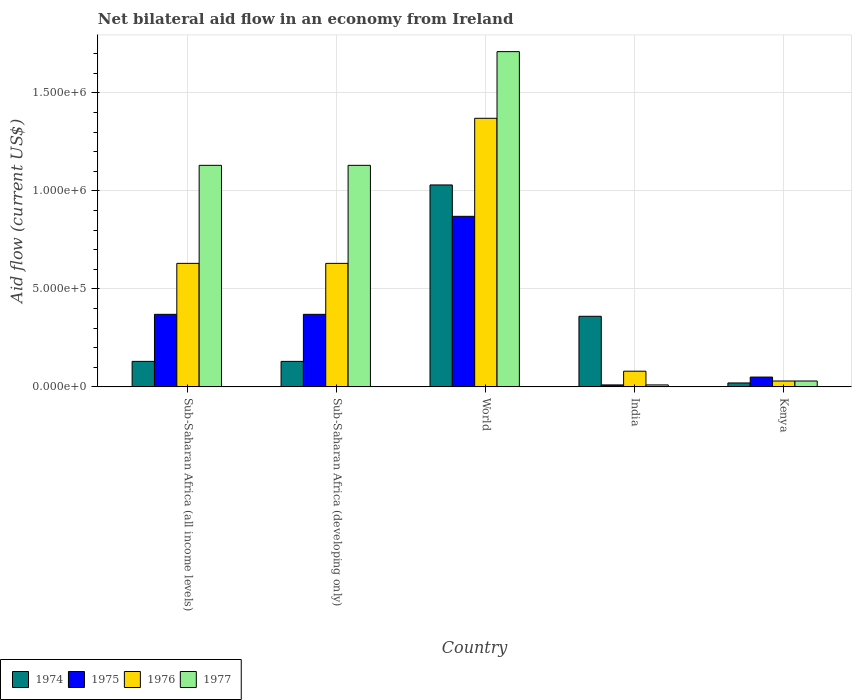How many different coloured bars are there?
Make the answer very short. 4. How many groups of bars are there?
Give a very brief answer. 5. Are the number of bars on each tick of the X-axis equal?
Your answer should be very brief. Yes. How many bars are there on the 2nd tick from the left?
Give a very brief answer. 4. What is the label of the 4th group of bars from the left?
Ensure brevity in your answer.  India. What is the net bilateral aid flow in 1977 in World?
Offer a terse response. 1.71e+06. Across all countries, what is the maximum net bilateral aid flow in 1976?
Ensure brevity in your answer.  1.37e+06. Across all countries, what is the minimum net bilateral aid flow in 1975?
Ensure brevity in your answer.  10000. In which country was the net bilateral aid flow in 1977 minimum?
Your answer should be very brief. India. What is the total net bilateral aid flow in 1977 in the graph?
Provide a succinct answer. 4.01e+06. What is the difference between the net bilateral aid flow in 1976 in Sub-Saharan Africa (developing only) and that in World?
Provide a succinct answer. -7.40e+05. What is the difference between the net bilateral aid flow in 1976 in Kenya and the net bilateral aid flow in 1977 in Sub-Saharan Africa (developing only)?
Ensure brevity in your answer.  -1.10e+06. What is the average net bilateral aid flow in 1974 per country?
Your response must be concise. 3.34e+05. What is the difference between the net bilateral aid flow of/in 1976 and net bilateral aid flow of/in 1975 in India?
Ensure brevity in your answer.  7.00e+04. What is the ratio of the net bilateral aid flow in 1974 in India to that in Kenya?
Offer a terse response. 18. Is the net bilateral aid flow in 1977 in Sub-Saharan Africa (developing only) less than that in World?
Provide a short and direct response. Yes. What is the difference between the highest and the second highest net bilateral aid flow in 1977?
Provide a short and direct response. 5.80e+05. What is the difference between the highest and the lowest net bilateral aid flow in 1974?
Ensure brevity in your answer.  1.01e+06. In how many countries, is the net bilateral aid flow in 1977 greater than the average net bilateral aid flow in 1977 taken over all countries?
Make the answer very short. 3. What does the 3rd bar from the left in World represents?
Your answer should be very brief. 1976. What does the 2nd bar from the right in Sub-Saharan Africa (all income levels) represents?
Offer a very short reply. 1976. How many bars are there?
Your answer should be very brief. 20. Are all the bars in the graph horizontal?
Your answer should be very brief. No. Are the values on the major ticks of Y-axis written in scientific E-notation?
Your answer should be compact. Yes. Does the graph contain any zero values?
Make the answer very short. No. Where does the legend appear in the graph?
Provide a succinct answer. Bottom left. How many legend labels are there?
Give a very brief answer. 4. How are the legend labels stacked?
Give a very brief answer. Horizontal. What is the title of the graph?
Provide a succinct answer. Net bilateral aid flow in an economy from Ireland. What is the label or title of the X-axis?
Offer a very short reply. Country. What is the label or title of the Y-axis?
Give a very brief answer. Aid flow (current US$). What is the Aid flow (current US$) of 1974 in Sub-Saharan Africa (all income levels)?
Offer a terse response. 1.30e+05. What is the Aid flow (current US$) of 1976 in Sub-Saharan Africa (all income levels)?
Offer a terse response. 6.30e+05. What is the Aid flow (current US$) in 1977 in Sub-Saharan Africa (all income levels)?
Ensure brevity in your answer.  1.13e+06. What is the Aid flow (current US$) in 1974 in Sub-Saharan Africa (developing only)?
Provide a succinct answer. 1.30e+05. What is the Aid flow (current US$) in 1976 in Sub-Saharan Africa (developing only)?
Your answer should be compact. 6.30e+05. What is the Aid flow (current US$) of 1977 in Sub-Saharan Africa (developing only)?
Provide a succinct answer. 1.13e+06. What is the Aid flow (current US$) of 1974 in World?
Your response must be concise. 1.03e+06. What is the Aid flow (current US$) of 1975 in World?
Keep it short and to the point. 8.70e+05. What is the Aid flow (current US$) of 1976 in World?
Offer a very short reply. 1.37e+06. What is the Aid flow (current US$) of 1977 in World?
Offer a very short reply. 1.71e+06. What is the Aid flow (current US$) in 1974 in India?
Make the answer very short. 3.60e+05. What is the Aid flow (current US$) of 1976 in India?
Provide a succinct answer. 8.00e+04. What is the Aid flow (current US$) in 1974 in Kenya?
Provide a succinct answer. 2.00e+04. What is the Aid flow (current US$) in 1976 in Kenya?
Your answer should be very brief. 3.00e+04. Across all countries, what is the maximum Aid flow (current US$) in 1974?
Offer a terse response. 1.03e+06. Across all countries, what is the maximum Aid flow (current US$) in 1975?
Your response must be concise. 8.70e+05. Across all countries, what is the maximum Aid flow (current US$) of 1976?
Give a very brief answer. 1.37e+06. Across all countries, what is the maximum Aid flow (current US$) of 1977?
Offer a very short reply. 1.71e+06. Across all countries, what is the minimum Aid flow (current US$) in 1976?
Keep it short and to the point. 3.00e+04. Across all countries, what is the minimum Aid flow (current US$) of 1977?
Your answer should be very brief. 10000. What is the total Aid flow (current US$) in 1974 in the graph?
Provide a succinct answer. 1.67e+06. What is the total Aid flow (current US$) in 1975 in the graph?
Your answer should be compact. 1.67e+06. What is the total Aid flow (current US$) of 1976 in the graph?
Keep it short and to the point. 2.74e+06. What is the total Aid flow (current US$) in 1977 in the graph?
Your answer should be compact. 4.01e+06. What is the difference between the Aid flow (current US$) in 1976 in Sub-Saharan Africa (all income levels) and that in Sub-Saharan Africa (developing only)?
Your response must be concise. 0. What is the difference between the Aid flow (current US$) of 1974 in Sub-Saharan Africa (all income levels) and that in World?
Your answer should be very brief. -9.00e+05. What is the difference between the Aid flow (current US$) in 1975 in Sub-Saharan Africa (all income levels) and that in World?
Ensure brevity in your answer.  -5.00e+05. What is the difference between the Aid flow (current US$) of 1976 in Sub-Saharan Africa (all income levels) and that in World?
Give a very brief answer. -7.40e+05. What is the difference between the Aid flow (current US$) in 1977 in Sub-Saharan Africa (all income levels) and that in World?
Your answer should be very brief. -5.80e+05. What is the difference between the Aid flow (current US$) in 1974 in Sub-Saharan Africa (all income levels) and that in India?
Offer a terse response. -2.30e+05. What is the difference between the Aid flow (current US$) of 1977 in Sub-Saharan Africa (all income levels) and that in India?
Keep it short and to the point. 1.12e+06. What is the difference between the Aid flow (current US$) of 1975 in Sub-Saharan Africa (all income levels) and that in Kenya?
Your response must be concise. 3.20e+05. What is the difference between the Aid flow (current US$) in 1976 in Sub-Saharan Africa (all income levels) and that in Kenya?
Ensure brevity in your answer.  6.00e+05. What is the difference between the Aid flow (current US$) of 1977 in Sub-Saharan Africa (all income levels) and that in Kenya?
Your response must be concise. 1.10e+06. What is the difference between the Aid flow (current US$) of 1974 in Sub-Saharan Africa (developing only) and that in World?
Offer a very short reply. -9.00e+05. What is the difference between the Aid flow (current US$) of 1975 in Sub-Saharan Africa (developing only) and that in World?
Ensure brevity in your answer.  -5.00e+05. What is the difference between the Aid flow (current US$) of 1976 in Sub-Saharan Africa (developing only) and that in World?
Keep it short and to the point. -7.40e+05. What is the difference between the Aid flow (current US$) of 1977 in Sub-Saharan Africa (developing only) and that in World?
Ensure brevity in your answer.  -5.80e+05. What is the difference between the Aid flow (current US$) in 1977 in Sub-Saharan Africa (developing only) and that in India?
Provide a succinct answer. 1.12e+06. What is the difference between the Aid flow (current US$) in 1974 in Sub-Saharan Africa (developing only) and that in Kenya?
Provide a succinct answer. 1.10e+05. What is the difference between the Aid flow (current US$) in 1976 in Sub-Saharan Africa (developing only) and that in Kenya?
Keep it short and to the point. 6.00e+05. What is the difference between the Aid flow (current US$) of 1977 in Sub-Saharan Africa (developing only) and that in Kenya?
Keep it short and to the point. 1.10e+06. What is the difference between the Aid flow (current US$) of 1974 in World and that in India?
Make the answer very short. 6.70e+05. What is the difference between the Aid flow (current US$) in 1975 in World and that in India?
Make the answer very short. 8.60e+05. What is the difference between the Aid flow (current US$) in 1976 in World and that in India?
Provide a short and direct response. 1.29e+06. What is the difference between the Aid flow (current US$) in 1977 in World and that in India?
Provide a short and direct response. 1.70e+06. What is the difference between the Aid flow (current US$) in 1974 in World and that in Kenya?
Your answer should be compact. 1.01e+06. What is the difference between the Aid flow (current US$) in 1975 in World and that in Kenya?
Provide a short and direct response. 8.20e+05. What is the difference between the Aid flow (current US$) in 1976 in World and that in Kenya?
Your response must be concise. 1.34e+06. What is the difference between the Aid flow (current US$) in 1977 in World and that in Kenya?
Give a very brief answer. 1.68e+06. What is the difference between the Aid flow (current US$) of 1974 in Sub-Saharan Africa (all income levels) and the Aid flow (current US$) of 1976 in Sub-Saharan Africa (developing only)?
Provide a short and direct response. -5.00e+05. What is the difference between the Aid flow (current US$) of 1975 in Sub-Saharan Africa (all income levels) and the Aid flow (current US$) of 1976 in Sub-Saharan Africa (developing only)?
Your response must be concise. -2.60e+05. What is the difference between the Aid flow (current US$) of 1975 in Sub-Saharan Africa (all income levels) and the Aid flow (current US$) of 1977 in Sub-Saharan Africa (developing only)?
Provide a short and direct response. -7.60e+05. What is the difference between the Aid flow (current US$) in 1976 in Sub-Saharan Africa (all income levels) and the Aid flow (current US$) in 1977 in Sub-Saharan Africa (developing only)?
Provide a short and direct response. -5.00e+05. What is the difference between the Aid flow (current US$) in 1974 in Sub-Saharan Africa (all income levels) and the Aid flow (current US$) in 1975 in World?
Your response must be concise. -7.40e+05. What is the difference between the Aid flow (current US$) of 1974 in Sub-Saharan Africa (all income levels) and the Aid flow (current US$) of 1976 in World?
Give a very brief answer. -1.24e+06. What is the difference between the Aid flow (current US$) in 1974 in Sub-Saharan Africa (all income levels) and the Aid flow (current US$) in 1977 in World?
Your answer should be very brief. -1.58e+06. What is the difference between the Aid flow (current US$) in 1975 in Sub-Saharan Africa (all income levels) and the Aid flow (current US$) in 1977 in World?
Make the answer very short. -1.34e+06. What is the difference between the Aid flow (current US$) of 1976 in Sub-Saharan Africa (all income levels) and the Aid flow (current US$) of 1977 in World?
Your response must be concise. -1.08e+06. What is the difference between the Aid flow (current US$) of 1974 in Sub-Saharan Africa (all income levels) and the Aid flow (current US$) of 1975 in India?
Make the answer very short. 1.20e+05. What is the difference between the Aid flow (current US$) of 1975 in Sub-Saharan Africa (all income levels) and the Aid flow (current US$) of 1976 in India?
Offer a very short reply. 2.90e+05. What is the difference between the Aid flow (current US$) of 1975 in Sub-Saharan Africa (all income levels) and the Aid flow (current US$) of 1977 in India?
Your response must be concise. 3.60e+05. What is the difference between the Aid flow (current US$) of 1976 in Sub-Saharan Africa (all income levels) and the Aid flow (current US$) of 1977 in India?
Your answer should be very brief. 6.20e+05. What is the difference between the Aid flow (current US$) in 1974 in Sub-Saharan Africa (all income levels) and the Aid flow (current US$) in 1977 in Kenya?
Offer a very short reply. 1.00e+05. What is the difference between the Aid flow (current US$) in 1975 in Sub-Saharan Africa (all income levels) and the Aid flow (current US$) in 1976 in Kenya?
Provide a short and direct response. 3.40e+05. What is the difference between the Aid flow (current US$) of 1975 in Sub-Saharan Africa (all income levels) and the Aid flow (current US$) of 1977 in Kenya?
Your answer should be very brief. 3.40e+05. What is the difference between the Aid flow (current US$) of 1976 in Sub-Saharan Africa (all income levels) and the Aid flow (current US$) of 1977 in Kenya?
Offer a terse response. 6.00e+05. What is the difference between the Aid flow (current US$) in 1974 in Sub-Saharan Africa (developing only) and the Aid flow (current US$) in 1975 in World?
Offer a very short reply. -7.40e+05. What is the difference between the Aid flow (current US$) of 1974 in Sub-Saharan Africa (developing only) and the Aid flow (current US$) of 1976 in World?
Give a very brief answer. -1.24e+06. What is the difference between the Aid flow (current US$) in 1974 in Sub-Saharan Africa (developing only) and the Aid flow (current US$) in 1977 in World?
Your response must be concise. -1.58e+06. What is the difference between the Aid flow (current US$) of 1975 in Sub-Saharan Africa (developing only) and the Aid flow (current US$) of 1976 in World?
Offer a very short reply. -1.00e+06. What is the difference between the Aid flow (current US$) in 1975 in Sub-Saharan Africa (developing only) and the Aid flow (current US$) in 1977 in World?
Your answer should be very brief. -1.34e+06. What is the difference between the Aid flow (current US$) of 1976 in Sub-Saharan Africa (developing only) and the Aid flow (current US$) of 1977 in World?
Offer a very short reply. -1.08e+06. What is the difference between the Aid flow (current US$) in 1975 in Sub-Saharan Africa (developing only) and the Aid flow (current US$) in 1976 in India?
Keep it short and to the point. 2.90e+05. What is the difference between the Aid flow (current US$) in 1975 in Sub-Saharan Africa (developing only) and the Aid flow (current US$) in 1977 in India?
Offer a terse response. 3.60e+05. What is the difference between the Aid flow (current US$) of 1976 in Sub-Saharan Africa (developing only) and the Aid flow (current US$) of 1977 in India?
Offer a very short reply. 6.20e+05. What is the difference between the Aid flow (current US$) of 1974 in Sub-Saharan Africa (developing only) and the Aid flow (current US$) of 1975 in Kenya?
Provide a short and direct response. 8.00e+04. What is the difference between the Aid flow (current US$) of 1974 in Sub-Saharan Africa (developing only) and the Aid flow (current US$) of 1976 in Kenya?
Your answer should be very brief. 1.00e+05. What is the difference between the Aid flow (current US$) in 1975 in Sub-Saharan Africa (developing only) and the Aid flow (current US$) in 1977 in Kenya?
Make the answer very short. 3.40e+05. What is the difference between the Aid flow (current US$) in 1974 in World and the Aid flow (current US$) in 1975 in India?
Give a very brief answer. 1.02e+06. What is the difference between the Aid flow (current US$) in 1974 in World and the Aid flow (current US$) in 1976 in India?
Provide a short and direct response. 9.50e+05. What is the difference between the Aid flow (current US$) in 1974 in World and the Aid flow (current US$) in 1977 in India?
Ensure brevity in your answer.  1.02e+06. What is the difference between the Aid flow (current US$) of 1975 in World and the Aid flow (current US$) of 1976 in India?
Your answer should be very brief. 7.90e+05. What is the difference between the Aid flow (current US$) of 1975 in World and the Aid flow (current US$) of 1977 in India?
Your answer should be compact. 8.60e+05. What is the difference between the Aid flow (current US$) of 1976 in World and the Aid flow (current US$) of 1977 in India?
Ensure brevity in your answer.  1.36e+06. What is the difference between the Aid flow (current US$) in 1974 in World and the Aid flow (current US$) in 1975 in Kenya?
Give a very brief answer. 9.80e+05. What is the difference between the Aid flow (current US$) of 1974 in World and the Aid flow (current US$) of 1976 in Kenya?
Provide a short and direct response. 1.00e+06. What is the difference between the Aid flow (current US$) of 1975 in World and the Aid flow (current US$) of 1976 in Kenya?
Your answer should be very brief. 8.40e+05. What is the difference between the Aid flow (current US$) in 1975 in World and the Aid flow (current US$) in 1977 in Kenya?
Provide a succinct answer. 8.40e+05. What is the difference between the Aid flow (current US$) of 1976 in World and the Aid flow (current US$) of 1977 in Kenya?
Your answer should be compact. 1.34e+06. What is the difference between the Aid flow (current US$) in 1974 in India and the Aid flow (current US$) in 1976 in Kenya?
Offer a very short reply. 3.30e+05. What is the difference between the Aid flow (current US$) of 1975 in India and the Aid flow (current US$) of 1976 in Kenya?
Provide a short and direct response. -2.00e+04. What is the difference between the Aid flow (current US$) in 1976 in India and the Aid flow (current US$) in 1977 in Kenya?
Make the answer very short. 5.00e+04. What is the average Aid flow (current US$) of 1974 per country?
Keep it short and to the point. 3.34e+05. What is the average Aid flow (current US$) of 1975 per country?
Your response must be concise. 3.34e+05. What is the average Aid flow (current US$) of 1976 per country?
Provide a succinct answer. 5.48e+05. What is the average Aid flow (current US$) of 1977 per country?
Provide a short and direct response. 8.02e+05. What is the difference between the Aid flow (current US$) of 1974 and Aid flow (current US$) of 1975 in Sub-Saharan Africa (all income levels)?
Make the answer very short. -2.40e+05. What is the difference between the Aid flow (current US$) of 1974 and Aid flow (current US$) of 1976 in Sub-Saharan Africa (all income levels)?
Your response must be concise. -5.00e+05. What is the difference between the Aid flow (current US$) in 1974 and Aid flow (current US$) in 1977 in Sub-Saharan Africa (all income levels)?
Provide a short and direct response. -1.00e+06. What is the difference between the Aid flow (current US$) of 1975 and Aid flow (current US$) of 1976 in Sub-Saharan Africa (all income levels)?
Provide a short and direct response. -2.60e+05. What is the difference between the Aid flow (current US$) in 1975 and Aid flow (current US$) in 1977 in Sub-Saharan Africa (all income levels)?
Keep it short and to the point. -7.60e+05. What is the difference between the Aid flow (current US$) in 1976 and Aid flow (current US$) in 1977 in Sub-Saharan Africa (all income levels)?
Your answer should be very brief. -5.00e+05. What is the difference between the Aid flow (current US$) in 1974 and Aid flow (current US$) in 1976 in Sub-Saharan Africa (developing only)?
Provide a succinct answer. -5.00e+05. What is the difference between the Aid flow (current US$) in 1974 and Aid flow (current US$) in 1977 in Sub-Saharan Africa (developing only)?
Provide a short and direct response. -1.00e+06. What is the difference between the Aid flow (current US$) in 1975 and Aid flow (current US$) in 1976 in Sub-Saharan Africa (developing only)?
Your answer should be compact. -2.60e+05. What is the difference between the Aid flow (current US$) in 1975 and Aid flow (current US$) in 1977 in Sub-Saharan Africa (developing only)?
Make the answer very short. -7.60e+05. What is the difference between the Aid flow (current US$) of 1976 and Aid flow (current US$) of 1977 in Sub-Saharan Africa (developing only)?
Offer a terse response. -5.00e+05. What is the difference between the Aid flow (current US$) in 1974 and Aid flow (current US$) in 1975 in World?
Offer a terse response. 1.60e+05. What is the difference between the Aid flow (current US$) of 1974 and Aid flow (current US$) of 1976 in World?
Give a very brief answer. -3.40e+05. What is the difference between the Aid flow (current US$) of 1974 and Aid flow (current US$) of 1977 in World?
Your answer should be compact. -6.80e+05. What is the difference between the Aid flow (current US$) of 1975 and Aid flow (current US$) of 1976 in World?
Ensure brevity in your answer.  -5.00e+05. What is the difference between the Aid flow (current US$) in 1975 and Aid flow (current US$) in 1977 in World?
Provide a short and direct response. -8.40e+05. What is the difference between the Aid flow (current US$) of 1975 and Aid flow (current US$) of 1976 in India?
Provide a short and direct response. -7.00e+04. What is the difference between the Aid flow (current US$) of 1974 and Aid flow (current US$) of 1975 in Kenya?
Offer a very short reply. -3.00e+04. What is the difference between the Aid flow (current US$) in 1974 and Aid flow (current US$) in 1976 in Kenya?
Offer a terse response. -10000. What is the difference between the Aid flow (current US$) in 1975 and Aid flow (current US$) in 1976 in Kenya?
Offer a terse response. 2.00e+04. What is the ratio of the Aid flow (current US$) of 1974 in Sub-Saharan Africa (all income levels) to that in Sub-Saharan Africa (developing only)?
Your answer should be compact. 1. What is the ratio of the Aid flow (current US$) in 1975 in Sub-Saharan Africa (all income levels) to that in Sub-Saharan Africa (developing only)?
Provide a succinct answer. 1. What is the ratio of the Aid flow (current US$) in 1976 in Sub-Saharan Africa (all income levels) to that in Sub-Saharan Africa (developing only)?
Provide a short and direct response. 1. What is the ratio of the Aid flow (current US$) of 1974 in Sub-Saharan Africa (all income levels) to that in World?
Keep it short and to the point. 0.13. What is the ratio of the Aid flow (current US$) in 1975 in Sub-Saharan Africa (all income levels) to that in World?
Make the answer very short. 0.43. What is the ratio of the Aid flow (current US$) of 1976 in Sub-Saharan Africa (all income levels) to that in World?
Ensure brevity in your answer.  0.46. What is the ratio of the Aid flow (current US$) in 1977 in Sub-Saharan Africa (all income levels) to that in World?
Offer a very short reply. 0.66. What is the ratio of the Aid flow (current US$) in 1974 in Sub-Saharan Africa (all income levels) to that in India?
Make the answer very short. 0.36. What is the ratio of the Aid flow (current US$) in 1976 in Sub-Saharan Africa (all income levels) to that in India?
Offer a very short reply. 7.88. What is the ratio of the Aid flow (current US$) in 1977 in Sub-Saharan Africa (all income levels) to that in India?
Your response must be concise. 113. What is the ratio of the Aid flow (current US$) in 1975 in Sub-Saharan Africa (all income levels) to that in Kenya?
Offer a terse response. 7.4. What is the ratio of the Aid flow (current US$) of 1977 in Sub-Saharan Africa (all income levels) to that in Kenya?
Provide a succinct answer. 37.67. What is the ratio of the Aid flow (current US$) of 1974 in Sub-Saharan Africa (developing only) to that in World?
Offer a terse response. 0.13. What is the ratio of the Aid flow (current US$) of 1975 in Sub-Saharan Africa (developing only) to that in World?
Offer a terse response. 0.43. What is the ratio of the Aid flow (current US$) in 1976 in Sub-Saharan Africa (developing only) to that in World?
Your answer should be very brief. 0.46. What is the ratio of the Aid flow (current US$) in 1977 in Sub-Saharan Africa (developing only) to that in World?
Ensure brevity in your answer.  0.66. What is the ratio of the Aid flow (current US$) of 1974 in Sub-Saharan Africa (developing only) to that in India?
Provide a succinct answer. 0.36. What is the ratio of the Aid flow (current US$) in 1975 in Sub-Saharan Africa (developing only) to that in India?
Your answer should be very brief. 37. What is the ratio of the Aid flow (current US$) of 1976 in Sub-Saharan Africa (developing only) to that in India?
Your answer should be compact. 7.88. What is the ratio of the Aid flow (current US$) in 1977 in Sub-Saharan Africa (developing only) to that in India?
Keep it short and to the point. 113. What is the ratio of the Aid flow (current US$) of 1977 in Sub-Saharan Africa (developing only) to that in Kenya?
Give a very brief answer. 37.67. What is the ratio of the Aid flow (current US$) of 1974 in World to that in India?
Offer a terse response. 2.86. What is the ratio of the Aid flow (current US$) in 1976 in World to that in India?
Make the answer very short. 17.12. What is the ratio of the Aid flow (current US$) of 1977 in World to that in India?
Offer a very short reply. 171. What is the ratio of the Aid flow (current US$) in 1974 in World to that in Kenya?
Your answer should be very brief. 51.5. What is the ratio of the Aid flow (current US$) in 1975 in World to that in Kenya?
Your response must be concise. 17.4. What is the ratio of the Aid flow (current US$) in 1976 in World to that in Kenya?
Offer a very short reply. 45.67. What is the ratio of the Aid flow (current US$) of 1977 in World to that in Kenya?
Make the answer very short. 57. What is the ratio of the Aid flow (current US$) in 1975 in India to that in Kenya?
Keep it short and to the point. 0.2. What is the ratio of the Aid flow (current US$) in 1976 in India to that in Kenya?
Offer a very short reply. 2.67. What is the ratio of the Aid flow (current US$) in 1977 in India to that in Kenya?
Your answer should be very brief. 0.33. What is the difference between the highest and the second highest Aid flow (current US$) in 1974?
Your answer should be very brief. 6.70e+05. What is the difference between the highest and the second highest Aid flow (current US$) of 1975?
Provide a succinct answer. 5.00e+05. What is the difference between the highest and the second highest Aid flow (current US$) of 1976?
Offer a very short reply. 7.40e+05. What is the difference between the highest and the second highest Aid flow (current US$) of 1977?
Make the answer very short. 5.80e+05. What is the difference between the highest and the lowest Aid flow (current US$) in 1974?
Your answer should be very brief. 1.01e+06. What is the difference between the highest and the lowest Aid flow (current US$) in 1975?
Keep it short and to the point. 8.60e+05. What is the difference between the highest and the lowest Aid flow (current US$) of 1976?
Your answer should be compact. 1.34e+06. What is the difference between the highest and the lowest Aid flow (current US$) of 1977?
Your response must be concise. 1.70e+06. 